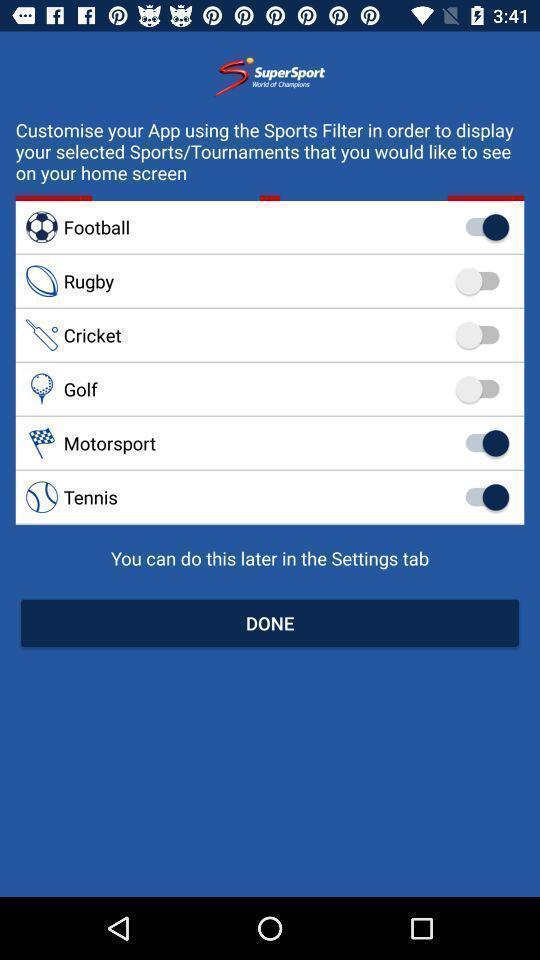Summarize the main components in this picture. Page showing selection options in a sports based app. 